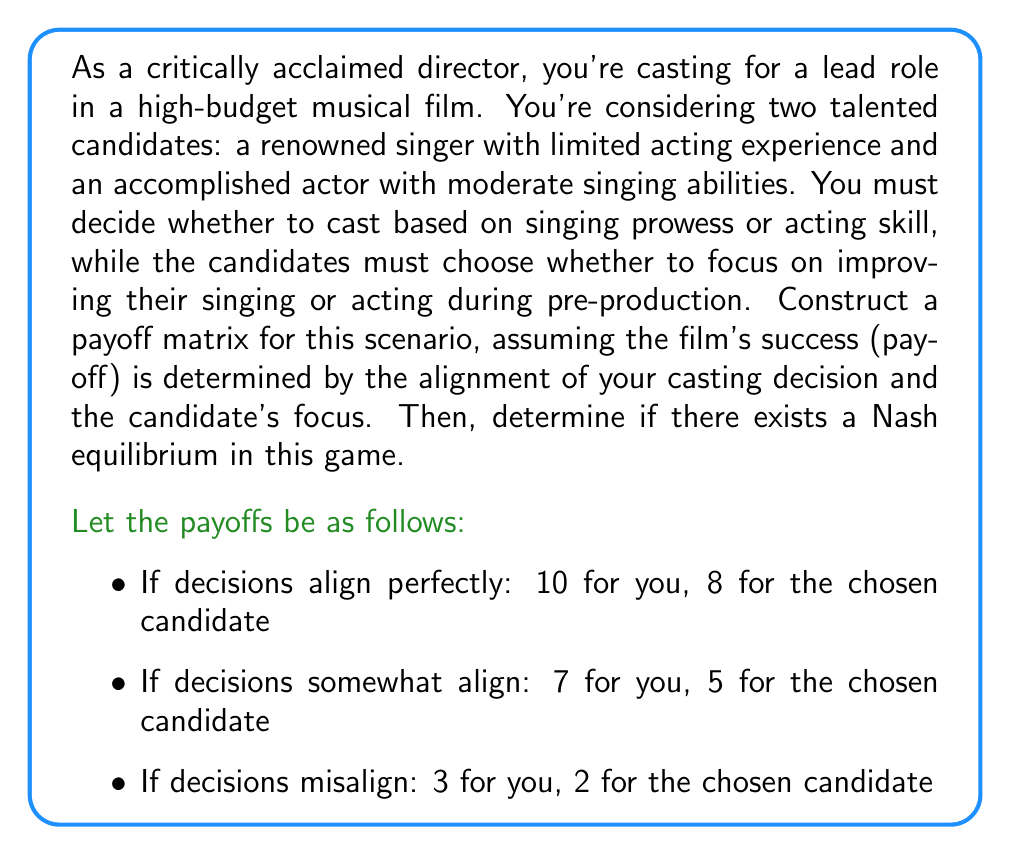Show me your answer to this math problem. To solve this problem, we need to construct the payoff matrix and then analyze it for Nash equilibria. Let's break it down step-by-step:

1. Construct the payoff matrix:

Let's define the strategies:
- Director: Cast based on Singing (S) or Acting (A)
- Candidate: Focus on improving Singing (S) or Acting (A)

The payoff matrix will be:

$$
\begin{array}{c|c|c}
 & \text{Candidate (S)} & \text{Candidate (A)} \\
\hline
\text{Director (S)} & (10,8) & (3,2) \\
\hline
\text{Director (A)} & (7,5) & (10,8)
\end{array}
$$

2. Analyze for Nash equilibria:

A Nash equilibrium occurs when no player can unilaterally change their strategy to increase their payoff. We need to check each strategy combination:

a) (Director S, Candidate S):
   - Director payoff: 10
   - If Director switches to A, payoff becomes 7
   - Candidate payoff: 8
   - If Candidate switches to A, payoff becomes 2
   Neither player benefits from switching, so this is a Nash equilibrium.

b) (Director S, Candidate A):
   - Director payoff: 3
   - If Director switches to A, payoff becomes 10
   - Director benefits from switching, so this is not a Nash equilibrium.

c) (Director A, Candidate S):
   - Candidate payoff: 5
   - If Candidate switches to A, payoff becomes 8
   - Candidate benefits from switching, so this is not a Nash equilibrium.

d) (Director A, Candidate A):
   - Director payoff: 10
   - If Director switches to S, payoff becomes 3
   - Candidate payoff: 8
   - If Candidate switches to S, payoff becomes 5
   Neither player benefits from switching, so this is a Nash equilibrium.

Therefore, we have found two Nash equilibria in this game: (Director S, Candidate S) and (Director A, Candidate A).
Answer: There are two Nash equilibria in this game:
1. (Director casts based on Singing, Candidate focuses on Singing)
2. (Director casts based on Acting, Candidate focuses on Acting) 